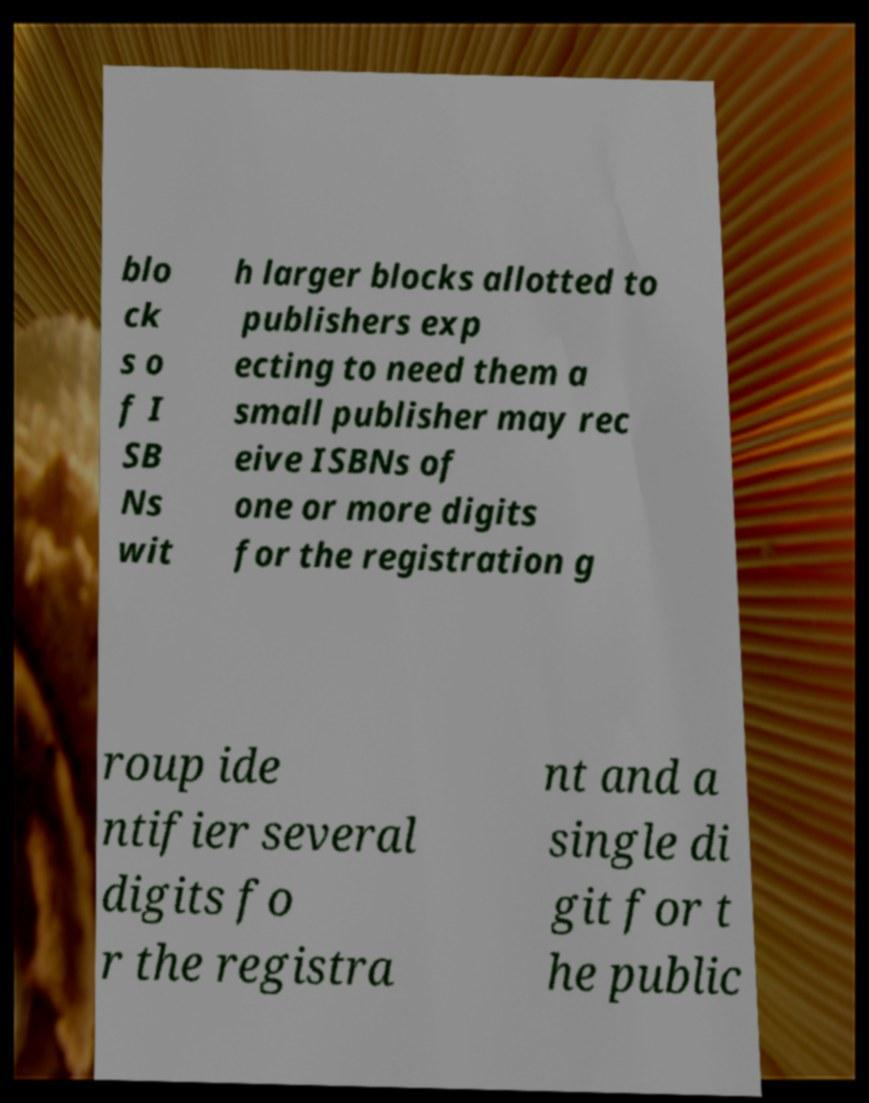Can you read and provide the text displayed in the image?This photo seems to have some interesting text. Can you extract and type it out for me? blo ck s o f I SB Ns wit h larger blocks allotted to publishers exp ecting to need them a small publisher may rec eive ISBNs of one or more digits for the registration g roup ide ntifier several digits fo r the registra nt and a single di git for t he public 